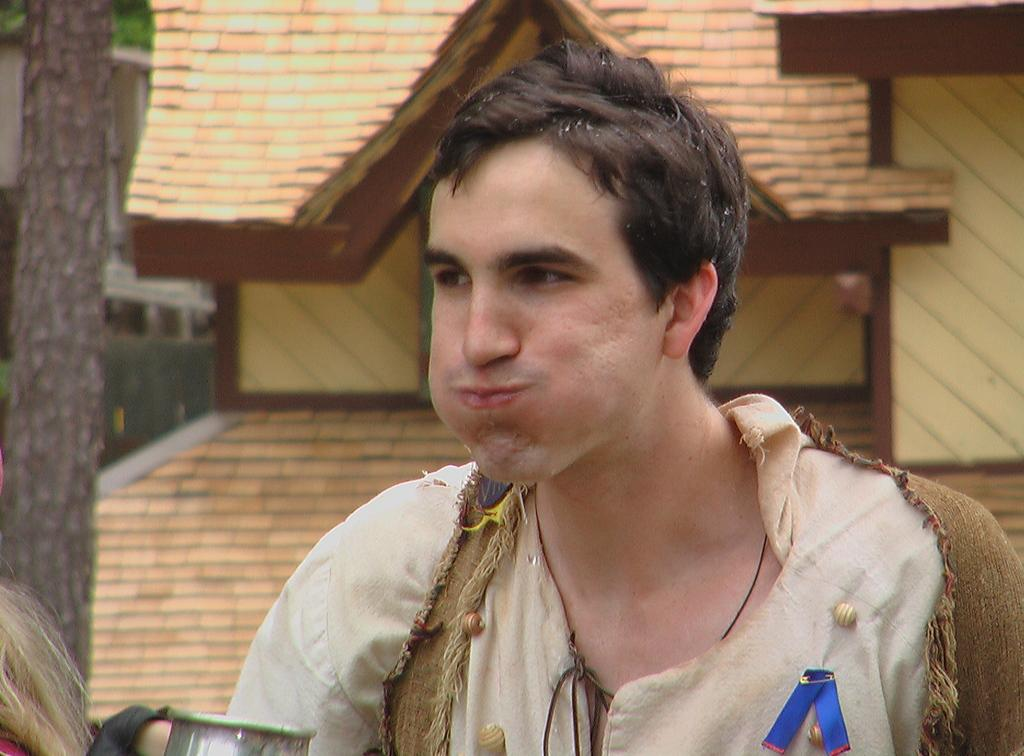Who or what is present in the image? There is a person in the image. What is the person wearing? The person is wearing a cream and brown color dress. What can be seen in the background of the image? There is a tree and a building in the background of the image. What is in-front of the person? There is an object or feature in-front of the person. How many cows are visible in the image? There are no cows present in the image. What rule is being followed by the person in the image? There is no rule being followed by the person in the image; we cannot determine their actions or intentions based on the provided facts. 